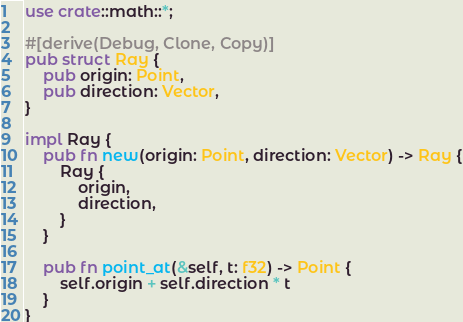<code> <loc_0><loc_0><loc_500><loc_500><_Rust_>use crate::math::*;

#[derive(Debug, Clone, Copy)]
pub struct Ray {
    pub origin: Point,
    pub direction: Vector,
}

impl Ray {
    pub fn new(origin: Point, direction: Vector) -> Ray {
        Ray {
            origin,
            direction,
        }
    }

    pub fn point_at(&self, t: f32) -> Point {
        self.origin + self.direction * t
    }
}</code> 